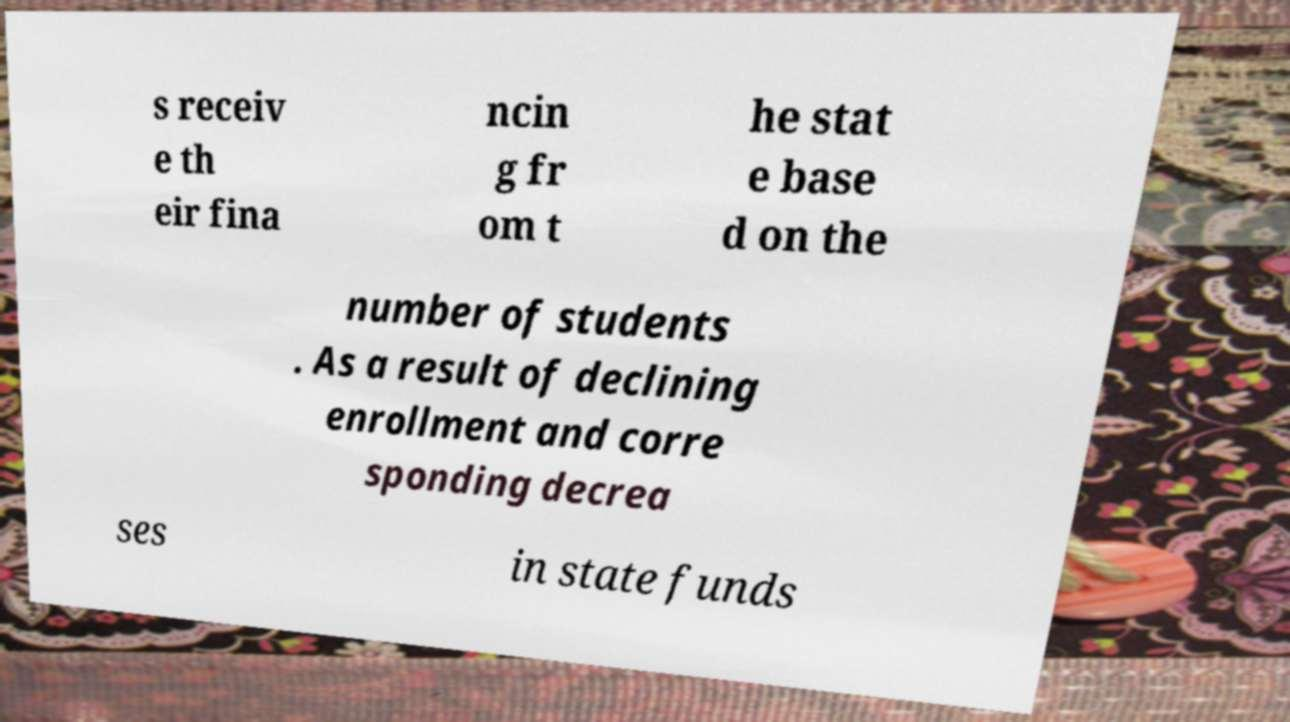For documentation purposes, I need the text within this image transcribed. Could you provide that? s receiv e th eir fina ncin g fr om t he stat e base d on the number of students . As a result of declining enrollment and corre sponding decrea ses in state funds 